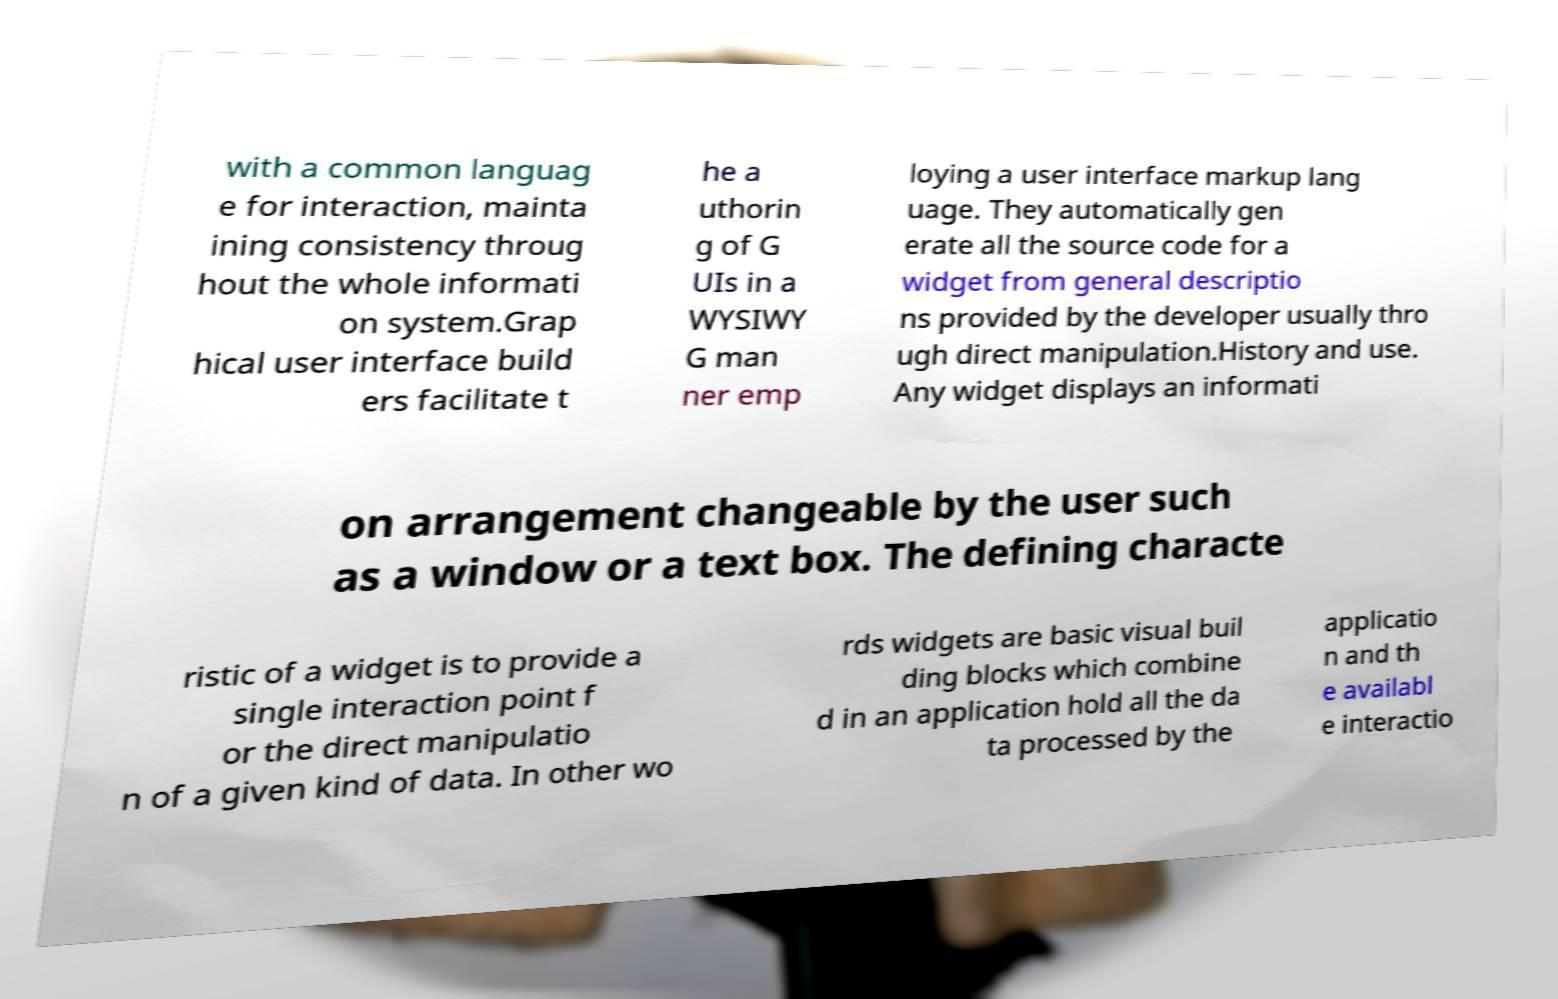Please identify and transcribe the text found in this image. with a common languag e for interaction, mainta ining consistency throug hout the whole informati on system.Grap hical user interface build ers facilitate t he a uthorin g of G UIs in a WYSIWY G man ner emp loying a user interface markup lang uage. They automatically gen erate all the source code for a widget from general descriptio ns provided by the developer usually thro ugh direct manipulation.History and use. Any widget displays an informati on arrangement changeable by the user such as a window or a text box. The defining characte ristic of a widget is to provide a single interaction point f or the direct manipulatio n of a given kind of data. In other wo rds widgets are basic visual buil ding blocks which combine d in an application hold all the da ta processed by the applicatio n and th e availabl e interactio 